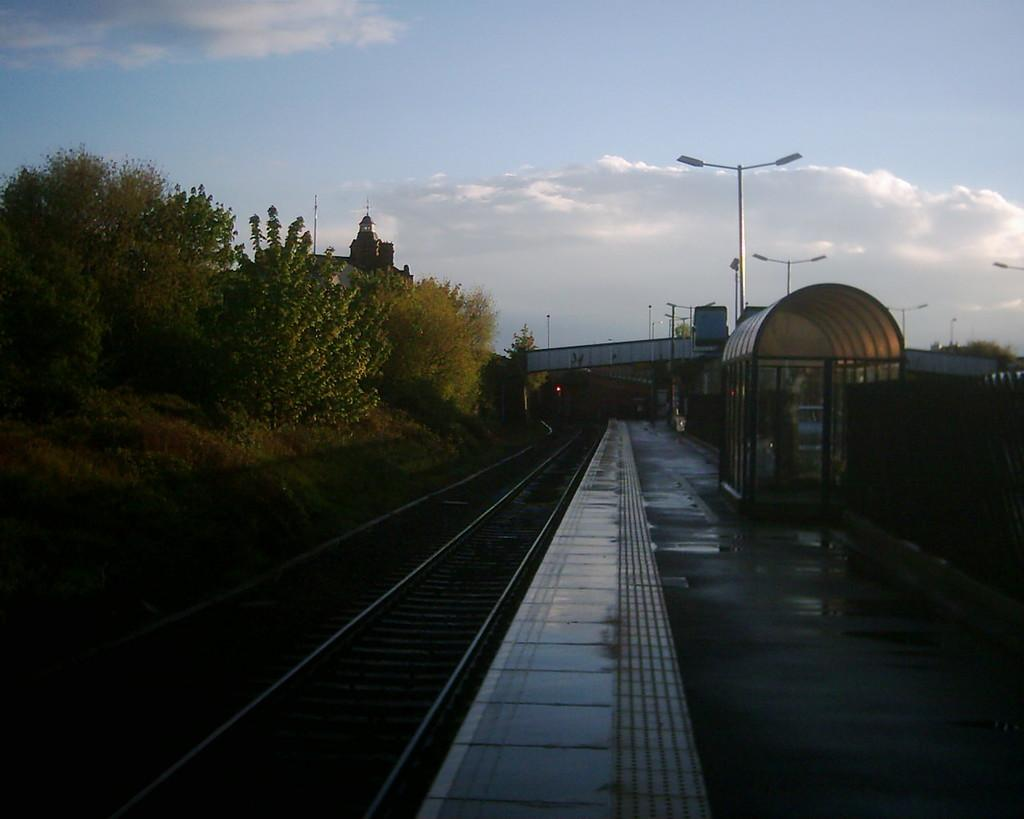What type of vegetation can be seen in the image? There are plants and trees in the image. What structures are present in the image? There are poles and a bridge in the image. What type of transportation infrastructure is visible in the image? Railway tracks are visible in the image. What is the ground like in the image? The ground has objects on it. What can be seen in the sky in the image? The sky is visible, and clouds are present in the image. What type of bun is being used to answer questions about the image? There is no bun present in the image, and it is not being used to answer questions about the image. What color is the silver object in the image? There is no silver object present in the image. 